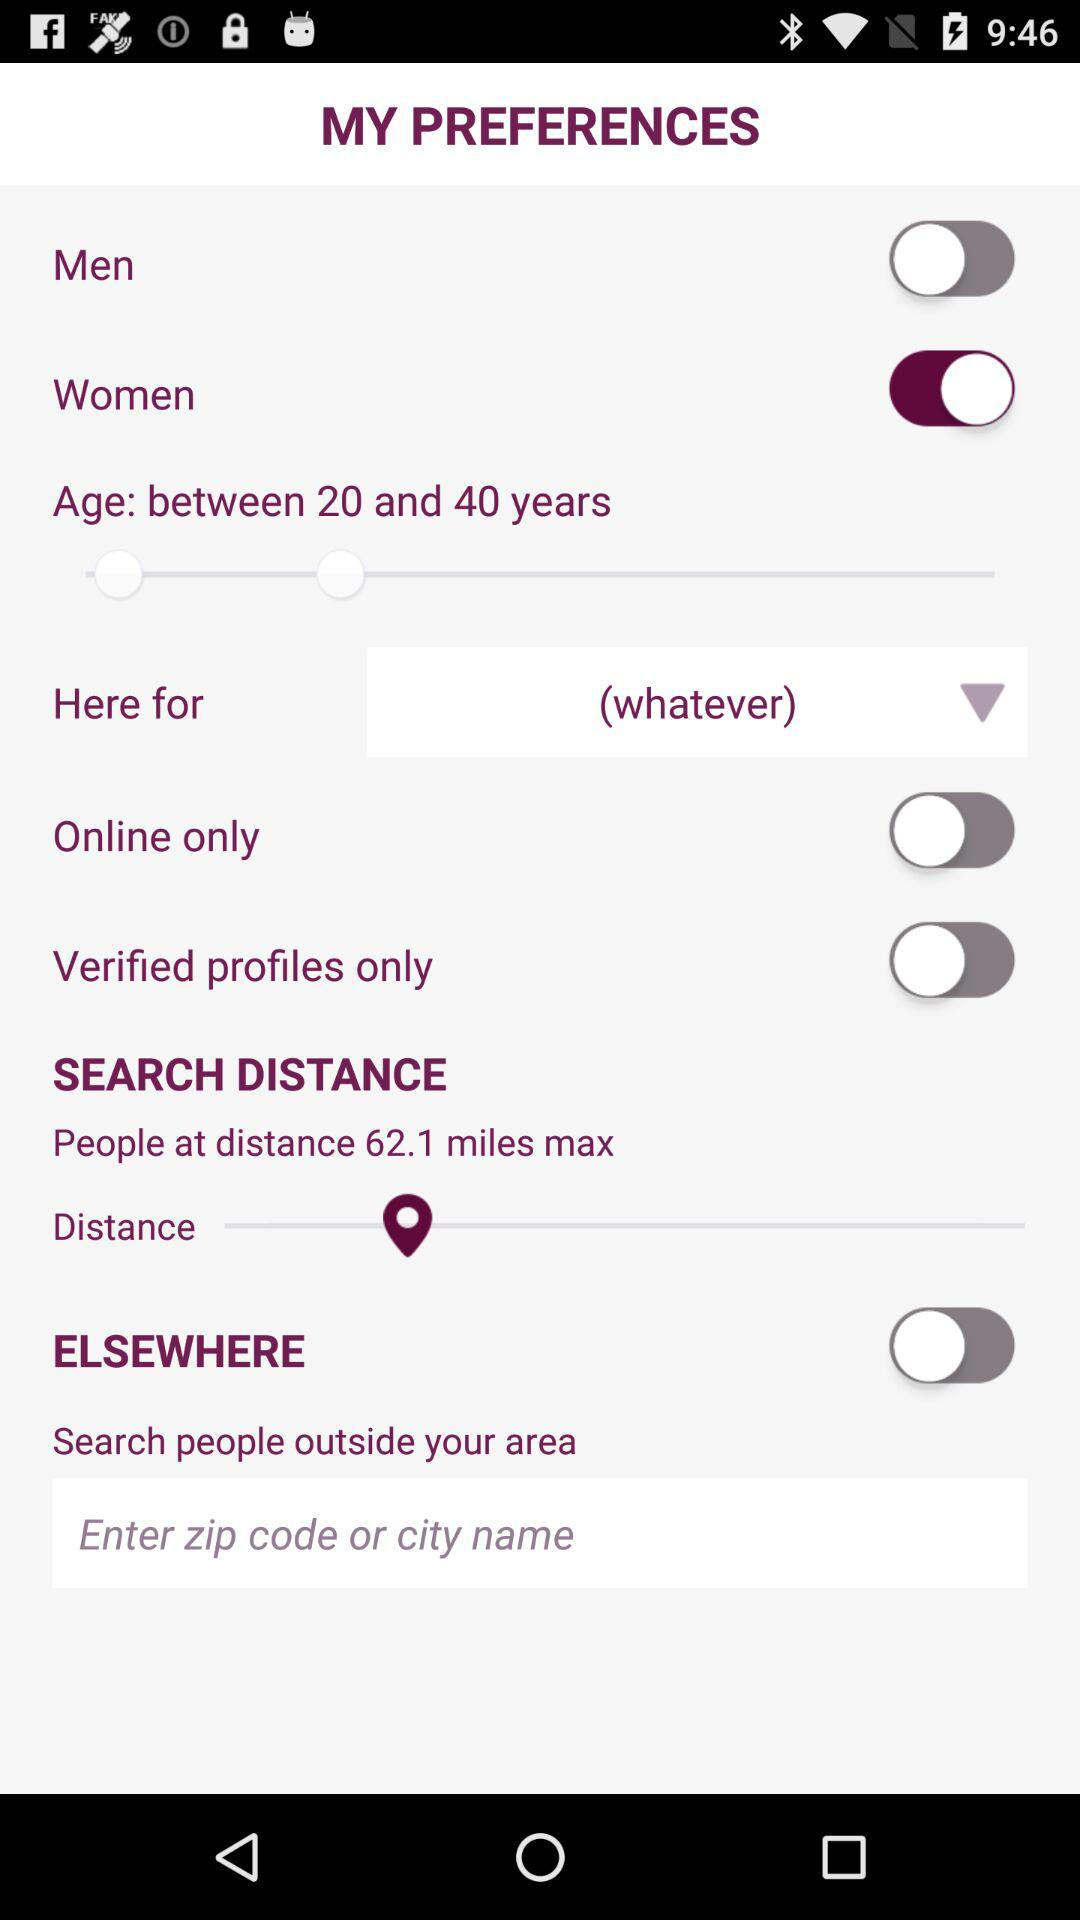What is the maximum search distance? The maximum search distance is 62.1 miles. 